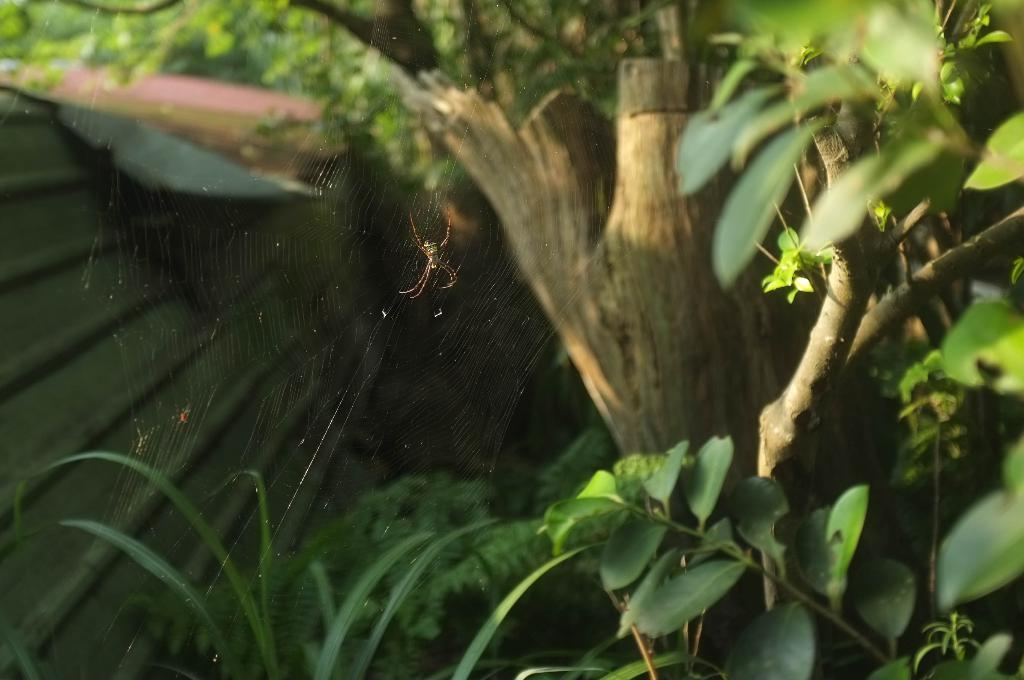What is the main subject of the image? There is a spider in the image. What is the spider associated with in the image? There is a spider web in the image. What type of vegetation is present in the image? There are green leaves in the image. What can be seen in the background of the image? There are trees visible in the background of the image. What type of journey is the spider taking in the image? There is no indication of a journey in the image; the spider is simply sitting on the spider web. 